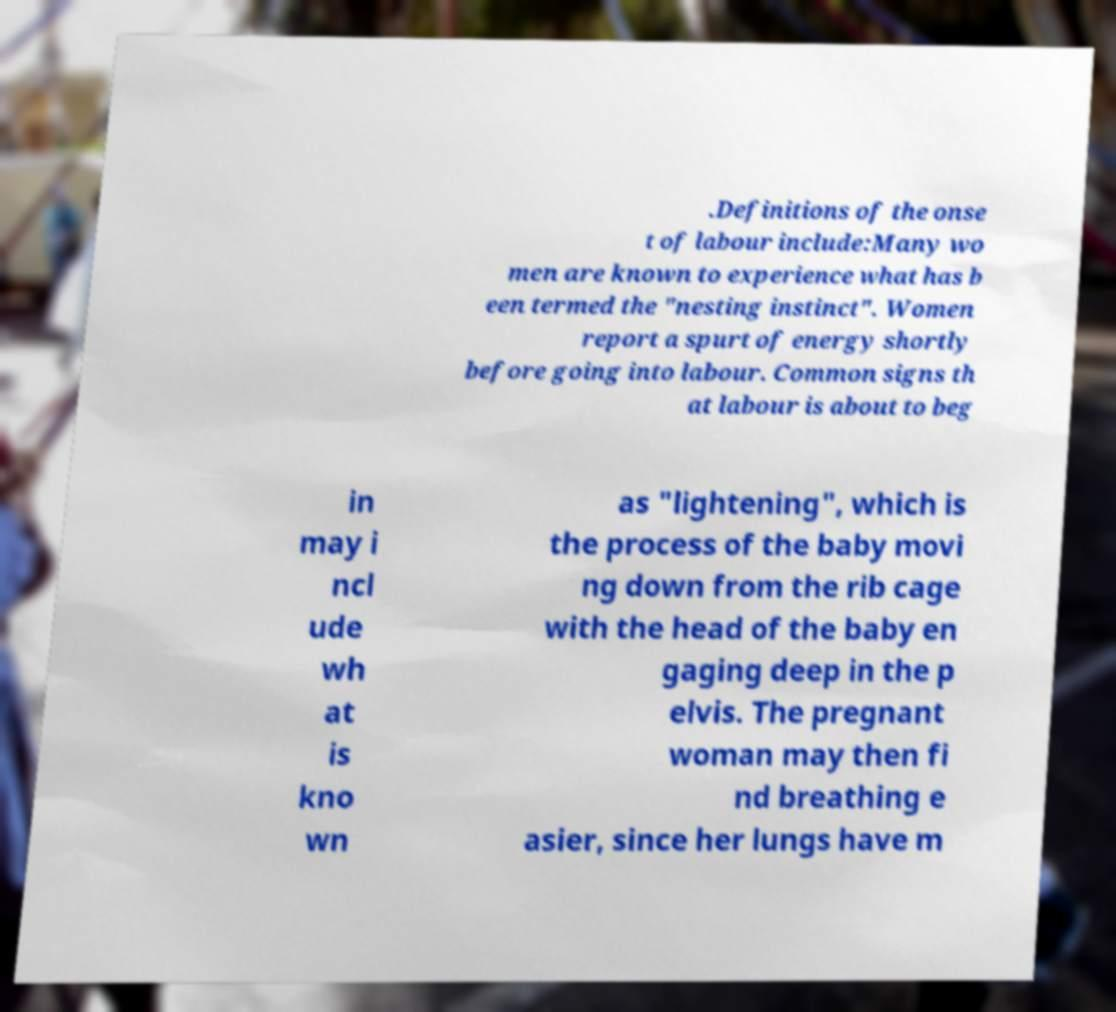For documentation purposes, I need the text within this image transcribed. Could you provide that? .Definitions of the onse t of labour include:Many wo men are known to experience what has b een termed the "nesting instinct". Women report a spurt of energy shortly before going into labour. Common signs th at labour is about to beg in may i ncl ude wh at is kno wn as "lightening", which is the process of the baby movi ng down from the rib cage with the head of the baby en gaging deep in the p elvis. The pregnant woman may then fi nd breathing e asier, since her lungs have m 